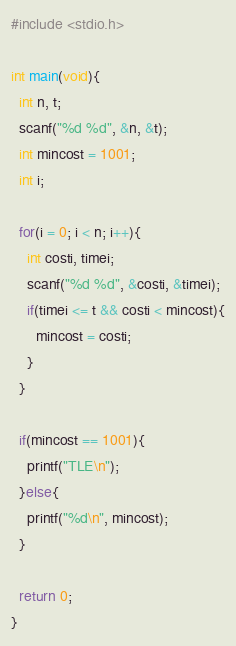<code> <loc_0><loc_0><loc_500><loc_500><_C_>#include <stdio.h>

int main(void){
  int n, t;
  scanf("%d %d", &n, &t);
  int mincost = 1001;
  int i;
  
  for(i = 0; i < n; i++){
    int costi, timei;
    scanf("%d %d", &costi, &timei);
    if(timei <= t && costi < mincost){
      mincost = costi;
    }
  }
  
  if(mincost == 1001){
    printf("TLE\n");
  }else{
    printf("%d\n", mincost);
  }
  
  return 0;
}</code> 